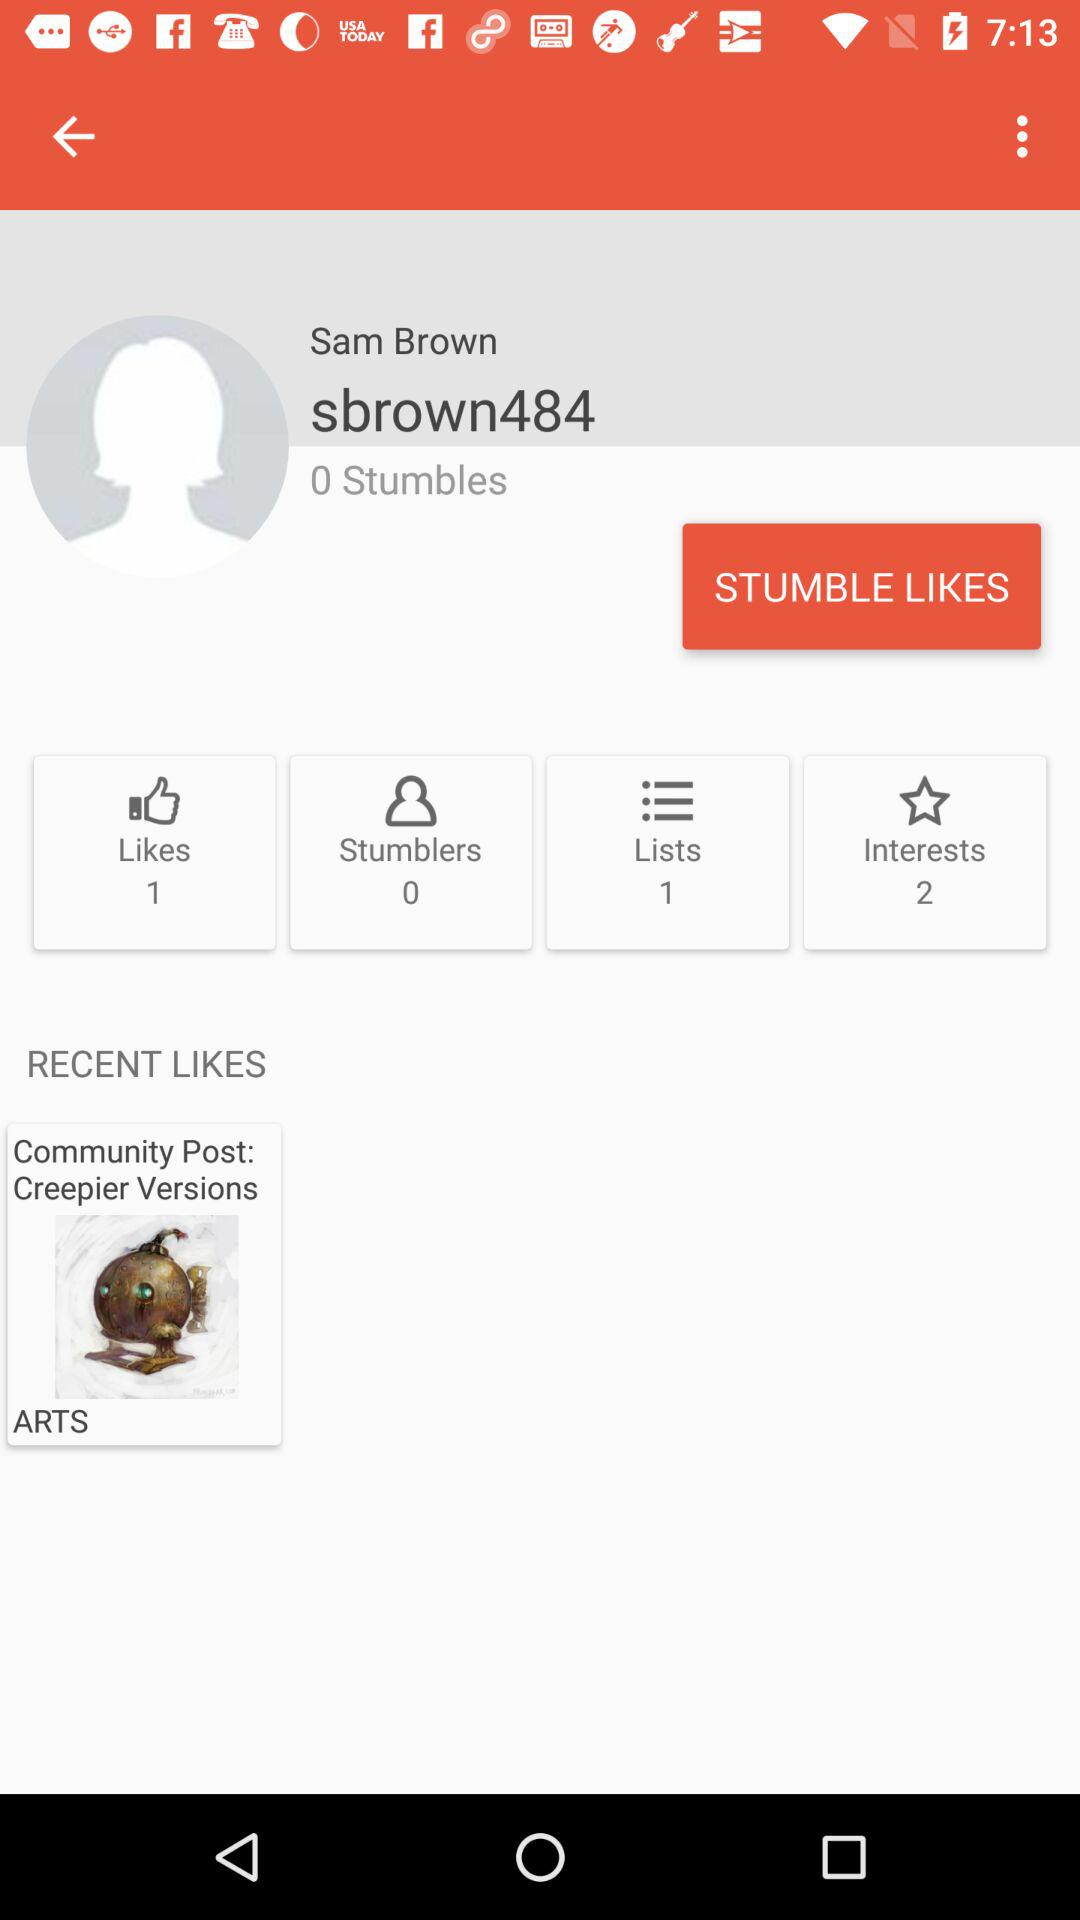How many more interests does Sam Brown have than stumbles?
Answer the question using a single word or phrase. 2 